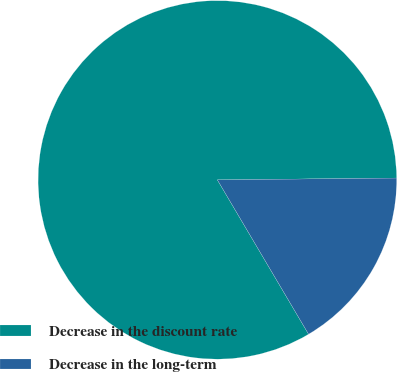Convert chart. <chart><loc_0><loc_0><loc_500><loc_500><pie_chart><fcel>Decrease in the discount rate<fcel>Decrease in the long-term<nl><fcel>83.33%<fcel>16.67%<nl></chart> 